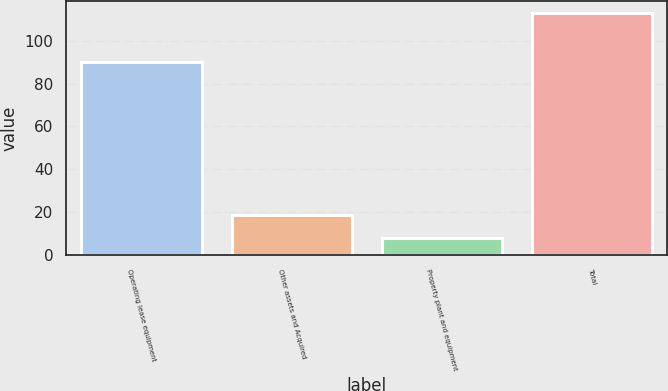Convert chart. <chart><loc_0><loc_0><loc_500><loc_500><bar_chart><fcel>Operating lease equipment<fcel>Other assets and Acquired<fcel>Property plant and equipment<fcel>Total<nl><fcel>90<fcel>18.5<fcel>8<fcel>113<nl></chart> 